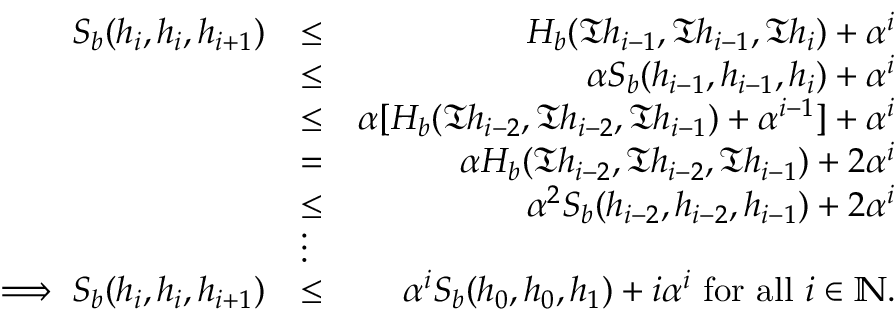<formula> <loc_0><loc_0><loc_500><loc_500>\begin{array} { r l r } { S _ { b } ( h _ { i } , h _ { i } , h _ { i + 1 } ) } & { \leq } & { H _ { b } ( \mathfrak { T } h _ { i - 1 } , \mathfrak { T } h _ { i - 1 } , \mathfrak { T } h _ { i } ) + \alpha ^ { i } } \\ & { \leq } & { \alpha S _ { b } ( h _ { i - 1 } , h _ { i - 1 } , h _ { i } ) + \alpha ^ { i } } \\ & { \leq } & { \alpha [ H _ { b } ( \mathfrak { T } h _ { i - 2 } , \mathfrak { T } h _ { i - 2 } , \mathfrak { T } h _ { i - 1 } ) + \alpha ^ { i - 1 } ] + \alpha ^ { i } } \\ & { = } & { \alpha H _ { b } ( \mathfrak { T } h _ { i - 2 } , \mathfrak { T } h _ { i - 2 } , \mathfrak { T } h _ { i - 1 } ) + 2 \alpha ^ { i } } \\ & { \leq } & { \alpha ^ { 2 } S _ { b } ( h _ { i - 2 } , h _ { i - 2 } , h _ { i - 1 } ) + 2 \alpha ^ { i } } \\ & { \vdots } & \\ { \implies S _ { b } ( h _ { i } , h _ { i } , h _ { i + 1 } ) } & { \leq } & { \alpha ^ { i } S _ { b } ( h _ { 0 } , h _ { 0 } , h _ { 1 } ) + i \alpha ^ { i } f o r a l l i \in \mathbb { N } . } \end{array}</formula> 